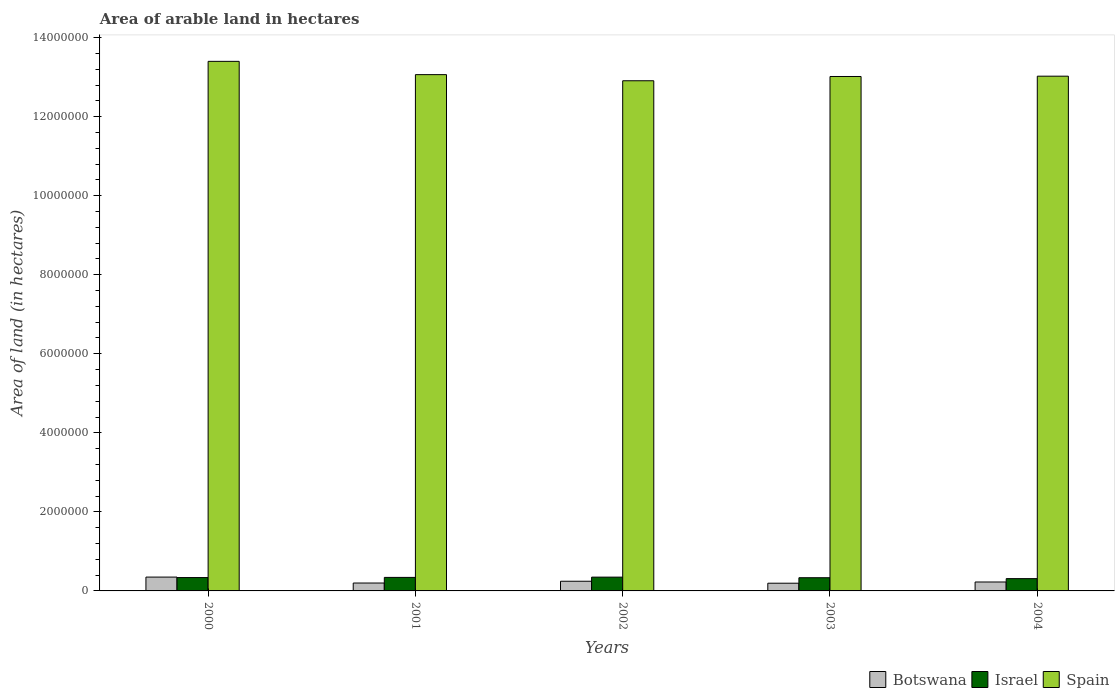How many groups of bars are there?
Make the answer very short. 5. Are the number of bars per tick equal to the number of legend labels?
Make the answer very short. Yes. Are the number of bars on each tick of the X-axis equal?
Your answer should be compact. Yes. In how many cases, is the number of bars for a given year not equal to the number of legend labels?
Make the answer very short. 0. What is the total arable land in Spain in 2001?
Your response must be concise. 1.31e+07. Across all years, what is the maximum total arable land in Israel?
Provide a succinct answer. 3.49e+05. Across all years, what is the minimum total arable land in Israel?
Make the answer very short. 3.11e+05. In which year was the total arable land in Spain maximum?
Your answer should be compact. 2000. In which year was the total arable land in Israel minimum?
Make the answer very short. 2004. What is the total total arable land in Botswana in the graph?
Ensure brevity in your answer.  1.22e+06. What is the difference between the total arable land in Spain in 2001 and that in 2003?
Make the answer very short. 4.70e+04. What is the difference between the total arable land in Israel in 2000 and the total arable land in Botswana in 2004?
Provide a succinct answer. 1.12e+05. What is the average total arable land in Spain per year?
Your response must be concise. 1.31e+07. In the year 2003, what is the difference between the total arable land in Botswana and total arable land in Spain?
Provide a succinct answer. -1.28e+07. In how many years, is the total arable land in Spain greater than 11600000 hectares?
Give a very brief answer. 5. What is the ratio of the total arable land in Israel in 2001 to that in 2004?
Offer a terse response. 1.1. Is the total arable land in Israel in 2000 less than that in 2002?
Keep it short and to the point. Yes. Is the difference between the total arable land in Botswana in 2000 and 2002 greater than the difference between the total arable land in Spain in 2000 and 2002?
Make the answer very short. No. What is the difference between the highest and the second highest total arable land in Botswana?
Give a very brief answer. 1.05e+05. What is the difference between the highest and the lowest total arable land in Botswana?
Make the answer very short. 1.55e+05. In how many years, is the total arable land in Botswana greater than the average total arable land in Botswana taken over all years?
Your answer should be very brief. 2. Is the sum of the total arable land in Botswana in 2002 and 2003 greater than the maximum total arable land in Israel across all years?
Your response must be concise. Yes. What does the 1st bar from the left in 2003 represents?
Offer a very short reply. Botswana. What does the 3rd bar from the right in 2002 represents?
Keep it short and to the point. Botswana. Are the values on the major ticks of Y-axis written in scientific E-notation?
Provide a short and direct response. No. Does the graph contain any zero values?
Provide a succinct answer. No. Does the graph contain grids?
Ensure brevity in your answer.  No. Where does the legend appear in the graph?
Provide a short and direct response. Bottom right. How many legend labels are there?
Your answer should be compact. 3. What is the title of the graph?
Offer a very short reply. Area of arable land in hectares. Does "St. Lucia" appear as one of the legend labels in the graph?
Keep it short and to the point. No. What is the label or title of the X-axis?
Provide a short and direct response. Years. What is the label or title of the Y-axis?
Offer a terse response. Area of land (in hectares). What is the Area of land (in hectares) in Botswana in 2000?
Your response must be concise. 3.50e+05. What is the Area of land (in hectares) of Israel in 2000?
Ensure brevity in your answer.  3.38e+05. What is the Area of land (in hectares) of Spain in 2000?
Keep it short and to the point. 1.34e+07. What is the Area of land (in hectares) in Israel in 2001?
Provide a short and direct response. 3.42e+05. What is the Area of land (in hectares) in Spain in 2001?
Make the answer very short. 1.31e+07. What is the Area of land (in hectares) of Botswana in 2002?
Your answer should be very brief. 2.45e+05. What is the Area of land (in hectares) in Israel in 2002?
Keep it short and to the point. 3.49e+05. What is the Area of land (in hectares) in Spain in 2002?
Make the answer very short. 1.29e+07. What is the Area of land (in hectares) in Botswana in 2003?
Make the answer very short. 1.95e+05. What is the Area of land (in hectares) of Israel in 2003?
Offer a terse response. 3.34e+05. What is the Area of land (in hectares) of Spain in 2003?
Provide a short and direct response. 1.30e+07. What is the Area of land (in hectares) of Botswana in 2004?
Give a very brief answer. 2.26e+05. What is the Area of land (in hectares) of Israel in 2004?
Provide a succinct answer. 3.11e+05. What is the Area of land (in hectares) of Spain in 2004?
Offer a terse response. 1.30e+07. Across all years, what is the maximum Area of land (in hectares) of Israel?
Ensure brevity in your answer.  3.49e+05. Across all years, what is the maximum Area of land (in hectares) in Spain?
Your answer should be compact. 1.34e+07. Across all years, what is the minimum Area of land (in hectares) of Botswana?
Your response must be concise. 1.95e+05. Across all years, what is the minimum Area of land (in hectares) in Israel?
Ensure brevity in your answer.  3.11e+05. Across all years, what is the minimum Area of land (in hectares) of Spain?
Ensure brevity in your answer.  1.29e+07. What is the total Area of land (in hectares) of Botswana in the graph?
Your response must be concise. 1.22e+06. What is the total Area of land (in hectares) in Israel in the graph?
Provide a succinct answer. 1.67e+06. What is the total Area of land (in hectares) in Spain in the graph?
Offer a terse response. 6.54e+07. What is the difference between the Area of land (in hectares) in Israel in 2000 and that in 2001?
Give a very brief answer. -4000. What is the difference between the Area of land (in hectares) in Spain in 2000 and that in 2001?
Your response must be concise. 3.36e+05. What is the difference between the Area of land (in hectares) of Botswana in 2000 and that in 2002?
Provide a short and direct response. 1.05e+05. What is the difference between the Area of land (in hectares) in Israel in 2000 and that in 2002?
Provide a succinct answer. -1.10e+04. What is the difference between the Area of land (in hectares) in Spain in 2000 and that in 2002?
Your response must be concise. 4.91e+05. What is the difference between the Area of land (in hectares) of Botswana in 2000 and that in 2003?
Your response must be concise. 1.55e+05. What is the difference between the Area of land (in hectares) of Israel in 2000 and that in 2003?
Make the answer very short. 4000. What is the difference between the Area of land (in hectares) of Spain in 2000 and that in 2003?
Your response must be concise. 3.83e+05. What is the difference between the Area of land (in hectares) in Botswana in 2000 and that in 2004?
Make the answer very short. 1.24e+05. What is the difference between the Area of land (in hectares) of Israel in 2000 and that in 2004?
Your response must be concise. 2.70e+04. What is the difference between the Area of land (in hectares) of Spain in 2000 and that in 2004?
Keep it short and to the point. 3.75e+05. What is the difference between the Area of land (in hectares) of Botswana in 2001 and that in 2002?
Give a very brief answer. -4.50e+04. What is the difference between the Area of land (in hectares) of Israel in 2001 and that in 2002?
Provide a short and direct response. -7000. What is the difference between the Area of land (in hectares) of Spain in 2001 and that in 2002?
Give a very brief answer. 1.55e+05. What is the difference between the Area of land (in hectares) in Israel in 2001 and that in 2003?
Make the answer very short. 8000. What is the difference between the Area of land (in hectares) in Spain in 2001 and that in 2003?
Provide a succinct answer. 4.70e+04. What is the difference between the Area of land (in hectares) in Botswana in 2001 and that in 2004?
Make the answer very short. -2.60e+04. What is the difference between the Area of land (in hectares) of Israel in 2001 and that in 2004?
Provide a succinct answer. 3.10e+04. What is the difference between the Area of land (in hectares) in Spain in 2001 and that in 2004?
Your response must be concise. 3.90e+04. What is the difference between the Area of land (in hectares) of Israel in 2002 and that in 2003?
Offer a very short reply. 1.50e+04. What is the difference between the Area of land (in hectares) in Spain in 2002 and that in 2003?
Offer a very short reply. -1.08e+05. What is the difference between the Area of land (in hectares) of Botswana in 2002 and that in 2004?
Your response must be concise. 1.90e+04. What is the difference between the Area of land (in hectares) in Israel in 2002 and that in 2004?
Your answer should be very brief. 3.80e+04. What is the difference between the Area of land (in hectares) in Spain in 2002 and that in 2004?
Provide a short and direct response. -1.16e+05. What is the difference between the Area of land (in hectares) of Botswana in 2003 and that in 2004?
Give a very brief answer. -3.10e+04. What is the difference between the Area of land (in hectares) in Israel in 2003 and that in 2004?
Offer a terse response. 2.30e+04. What is the difference between the Area of land (in hectares) in Spain in 2003 and that in 2004?
Offer a very short reply. -8000. What is the difference between the Area of land (in hectares) of Botswana in 2000 and the Area of land (in hectares) of Israel in 2001?
Provide a short and direct response. 8000. What is the difference between the Area of land (in hectares) of Botswana in 2000 and the Area of land (in hectares) of Spain in 2001?
Your answer should be compact. -1.27e+07. What is the difference between the Area of land (in hectares) in Israel in 2000 and the Area of land (in hectares) in Spain in 2001?
Offer a terse response. -1.27e+07. What is the difference between the Area of land (in hectares) of Botswana in 2000 and the Area of land (in hectares) of Israel in 2002?
Offer a very short reply. 1000. What is the difference between the Area of land (in hectares) of Botswana in 2000 and the Area of land (in hectares) of Spain in 2002?
Give a very brief answer. -1.26e+07. What is the difference between the Area of land (in hectares) of Israel in 2000 and the Area of land (in hectares) of Spain in 2002?
Ensure brevity in your answer.  -1.26e+07. What is the difference between the Area of land (in hectares) of Botswana in 2000 and the Area of land (in hectares) of Israel in 2003?
Keep it short and to the point. 1.60e+04. What is the difference between the Area of land (in hectares) in Botswana in 2000 and the Area of land (in hectares) in Spain in 2003?
Provide a short and direct response. -1.27e+07. What is the difference between the Area of land (in hectares) of Israel in 2000 and the Area of land (in hectares) of Spain in 2003?
Provide a succinct answer. -1.27e+07. What is the difference between the Area of land (in hectares) in Botswana in 2000 and the Area of land (in hectares) in Israel in 2004?
Provide a short and direct response. 3.90e+04. What is the difference between the Area of land (in hectares) of Botswana in 2000 and the Area of land (in hectares) of Spain in 2004?
Ensure brevity in your answer.  -1.27e+07. What is the difference between the Area of land (in hectares) of Israel in 2000 and the Area of land (in hectares) of Spain in 2004?
Your response must be concise. -1.27e+07. What is the difference between the Area of land (in hectares) of Botswana in 2001 and the Area of land (in hectares) of Israel in 2002?
Make the answer very short. -1.49e+05. What is the difference between the Area of land (in hectares) of Botswana in 2001 and the Area of land (in hectares) of Spain in 2002?
Offer a terse response. -1.27e+07. What is the difference between the Area of land (in hectares) of Israel in 2001 and the Area of land (in hectares) of Spain in 2002?
Provide a short and direct response. -1.26e+07. What is the difference between the Area of land (in hectares) of Botswana in 2001 and the Area of land (in hectares) of Israel in 2003?
Your response must be concise. -1.34e+05. What is the difference between the Area of land (in hectares) in Botswana in 2001 and the Area of land (in hectares) in Spain in 2003?
Make the answer very short. -1.28e+07. What is the difference between the Area of land (in hectares) in Israel in 2001 and the Area of land (in hectares) in Spain in 2003?
Keep it short and to the point. -1.27e+07. What is the difference between the Area of land (in hectares) of Botswana in 2001 and the Area of land (in hectares) of Israel in 2004?
Your answer should be compact. -1.11e+05. What is the difference between the Area of land (in hectares) in Botswana in 2001 and the Area of land (in hectares) in Spain in 2004?
Your answer should be compact. -1.28e+07. What is the difference between the Area of land (in hectares) of Israel in 2001 and the Area of land (in hectares) of Spain in 2004?
Offer a terse response. -1.27e+07. What is the difference between the Area of land (in hectares) in Botswana in 2002 and the Area of land (in hectares) in Israel in 2003?
Your response must be concise. -8.90e+04. What is the difference between the Area of land (in hectares) in Botswana in 2002 and the Area of land (in hectares) in Spain in 2003?
Ensure brevity in your answer.  -1.28e+07. What is the difference between the Area of land (in hectares) in Israel in 2002 and the Area of land (in hectares) in Spain in 2003?
Keep it short and to the point. -1.27e+07. What is the difference between the Area of land (in hectares) of Botswana in 2002 and the Area of land (in hectares) of Israel in 2004?
Offer a terse response. -6.60e+04. What is the difference between the Area of land (in hectares) in Botswana in 2002 and the Area of land (in hectares) in Spain in 2004?
Your answer should be very brief. -1.28e+07. What is the difference between the Area of land (in hectares) in Israel in 2002 and the Area of land (in hectares) in Spain in 2004?
Offer a very short reply. -1.27e+07. What is the difference between the Area of land (in hectares) in Botswana in 2003 and the Area of land (in hectares) in Israel in 2004?
Offer a terse response. -1.16e+05. What is the difference between the Area of land (in hectares) of Botswana in 2003 and the Area of land (in hectares) of Spain in 2004?
Your response must be concise. -1.28e+07. What is the difference between the Area of land (in hectares) of Israel in 2003 and the Area of land (in hectares) of Spain in 2004?
Your answer should be very brief. -1.27e+07. What is the average Area of land (in hectares) in Botswana per year?
Your answer should be compact. 2.43e+05. What is the average Area of land (in hectares) of Israel per year?
Your answer should be compact. 3.35e+05. What is the average Area of land (in hectares) of Spain per year?
Offer a very short reply. 1.31e+07. In the year 2000, what is the difference between the Area of land (in hectares) in Botswana and Area of land (in hectares) in Israel?
Provide a succinct answer. 1.20e+04. In the year 2000, what is the difference between the Area of land (in hectares) in Botswana and Area of land (in hectares) in Spain?
Your answer should be compact. -1.30e+07. In the year 2000, what is the difference between the Area of land (in hectares) in Israel and Area of land (in hectares) in Spain?
Your answer should be very brief. -1.31e+07. In the year 2001, what is the difference between the Area of land (in hectares) in Botswana and Area of land (in hectares) in Israel?
Offer a very short reply. -1.42e+05. In the year 2001, what is the difference between the Area of land (in hectares) in Botswana and Area of land (in hectares) in Spain?
Give a very brief answer. -1.29e+07. In the year 2001, what is the difference between the Area of land (in hectares) of Israel and Area of land (in hectares) of Spain?
Offer a very short reply. -1.27e+07. In the year 2002, what is the difference between the Area of land (in hectares) of Botswana and Area of land (in hectares) of Israel?
Your answer should be very brief. -1.04e+05. In the year 2002, what is the difference between the Area of land (in hectares) in Botswana and Area of land (in hectares) in Spain?
Provide a succinct answer. -1.27e+07. In the year 2002, what is the difference between the Area of land (in hectares) in Israel and Area of land (in hectares) in Spain?
Your answer should be compact. -1.26e+07. In the year 2003, what is the difference between the Area of land (in hectares) of Botswana and Area of land (in hectares) of Israel?
Make the answer very short. -1.39e+05. In the year 2003, what is the difference between the Area of land (in hectares) of Botswana and Area of land (in hectares) of Spain?
Your answer should be compact. -1.28e+07. In the year 2003, what is the difference between the Area of land (in hectares) in Israel and Area of land (in hectares) in Spain?
Give a very brief answer. -1.27e+07. In the year 2004, what is the difference between the Area of land (in hectares) of Botswana and Area of land (in hectares) of Israel?
Offer a terse response. -8.50e+04. In the year 2004, what is the difference between the Area of land (in hectares) in Botswana and Area of land (in hectares) in Spain?
Provide a succinct answer. -1.28e+07. In the year 2004, what is the difference between the Area of land (in hectares) in Israel and Area of land (in hectares) in Spain?
Offer a terse response. -1.27e+07. What is the ratio of the Area of land (in hectares) of Israel in 2000 to that in 2001?
Give a very brief answer. 0.99. What is the ratio of the Area of land (in hectares) in Spain in 2000 to that in 2001?
Make the answer very short. 1.03. What is the ratio of the Area of land (in hectares) in Botswana in 2000 to that in 2002?
Make the answer very short. 1.43. What is the ratio of the Area of land (in hectares) of Israel in 2000 to that in 2002?
Your response must be concise. 0.97. What is the ratio of the Area of land (in hectares) in Spain in 2000 to that in 2002?
Your answer should be very brief. 1.04. What is the ratio of the Area of land (in hectares) in Botswana in 2000 to that in 2003?
Your answer should be compact. 1.79. What is the ratio of the Area of land (in hectares) of Israel in 2000 to that in 2003?
Provide a short and direct response. 1.01. What is the ratio of the Area of land (in hectares) of Spain in 2000 to that in 2003?
Give a very brief answer. 1.03. What is the ratio of the Area of land (in hectares) in Botswana in 2000 to that in 2004?
Your answer should be compact. 1.55. What is the ratio of the Area of land (in hectares) in Israel in 2000 to that in 2004?
Your answer should be very brief. 1.09. What is the ratio of the Area of land (in hectares) of Spain in 2000 to that in 2004?
Provide a short and direct response. 1.03. What is the ratio of the Area of land (in hectares) of Botswana in 2001 to that in 2002?
Ensure brevity in your answer.  0.82. What is the ratio of the Area of land (in hectares) of Israel in 2001 to that in 2002?
Ensure brevity in your answer.  0.98. What is the ratio of the Area of land (in hectares) of Botswana in 2001 to that in 2003?
Offer a terse response. 1.03. What is the ratio of the Area of land (in hectares) in Israel in 2001 to that in 2003?
Make the answer very short. 1.02. What is the ratio of the Area of land (in hectares) of Botswana in 2001 to that in 2004?
Offer a very short reply. 0.89. What is the ratio of the Area of land (in hectares) of Israel in 2001 to that in 2004?
Your response must be concise. 1.1. What is the ratio of the Area of land (in hectares) of Botswana in 2002 to that in 2003?
Provide a succinct answer. 1.26. What is the ratio of the Area of land (in hectares) in Israel in 2002 to that in 2003?
Provide a succinct answer. 1.04. What is the ratio of the Area of land (in hectares) in Botswana in 2002 to that in 2004?
Give a very brief answer. 1.08. What is the ratio of the Area of land (in hectares) of Israel in 2002 to that in 2004?
Offer a terse response. 1.12. What is the ratio of the Area of land (in hectares) of Spain in 2002 to that in 2004?
Your answer should be very brief. 0.99. What is the ratio of the Area of land (in hectares) in Botswana in 2003 to that in 2004?
Ensure brevity in your answer.  0.86. What is the ratio of the Area of land (in hectares) of Israel in 2003 to that in 2004?
Your answer should be very brief. 1.07. What is the difference between the highest and the second highest Area of land (in hectares) in Botswana?
Make the answer very short. 1.05e+05. What is the difference between the highest and the second highest Area of land (in hectares) in Israel?
Offer a very short reply. 7000. What is the difference between the highest and the second highest Area of land (in hectares) of Spain?
Your answer should be compact. 3.36e+05. What is the difference between the highest and the lowest Area of land (in hectares) of Botswana?
Offer a very short reply. 1.55e+05. What is the difference between the highest and the lowest Area of land (in hectares) of Israel?
Provide a short and direct response. 3.80e+04. What is the difference between the highest and the lowest Area of land (in hectares) of Spain?
Ensure brevity in your answer.  4.91e+05. 